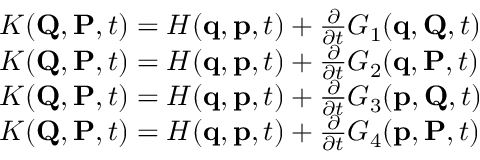Convert formula to latex. <formula><loc_0><loc_0><loc_500><loc_500>{ \begin{array} { r l } & { K ( Q , P , t ) = H ( q , p , t ) + { \frac { \partial } { \partial t } } G _ { 1 } ( q , Q , t ) } \\ & { K ( Q , P , t ) = H ( q , p , t ) + { \frac { \partial } { \partial t } } G _ { 2 } ( q , P , t ) } \\ & { K ( Q , P , t ) = H ( q , p , t ) + { \frac { \partial } { \partial t } } G _ { 3 } ( p , Q , t ) } \\ & { K ( Q , P , t ) = H ( q , p , t ) + { \frac { \partial } { \partial t } } G _ { 4 } ( p , P , t ) } \end{array} }</formula> 